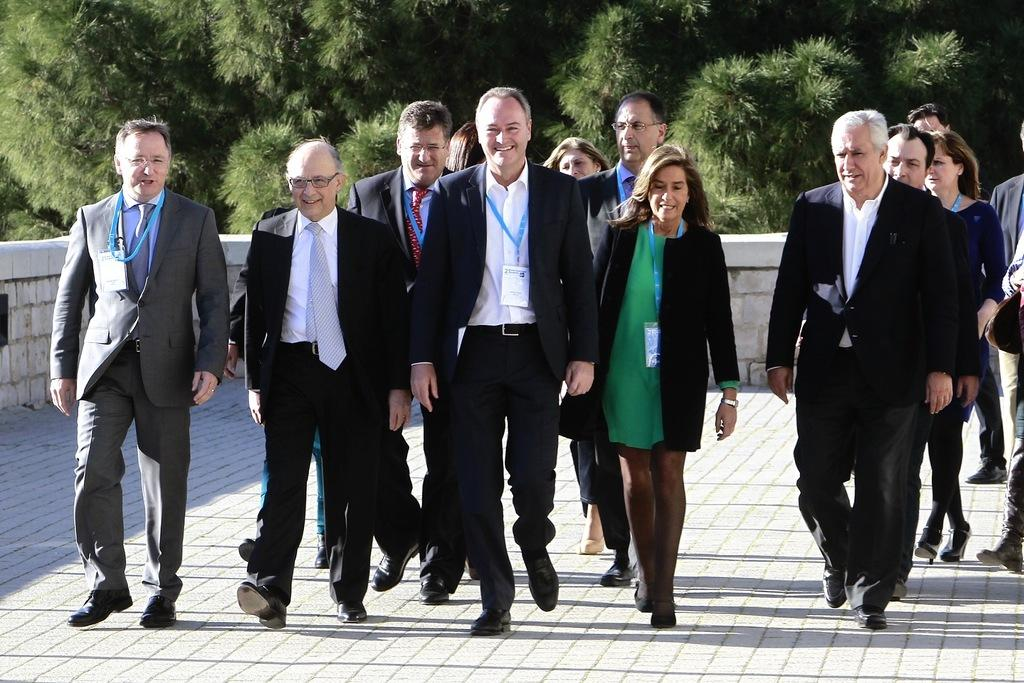What are the people in the image doing? The people in the image are walking on the road. What can be seen in the background of the image? There are trees visible in the background of the image. What type of insurance is being discussed by the people walking on the road in the image? There is no indication in the image that the people are discussing insurance, as they are simply walking on the road. 